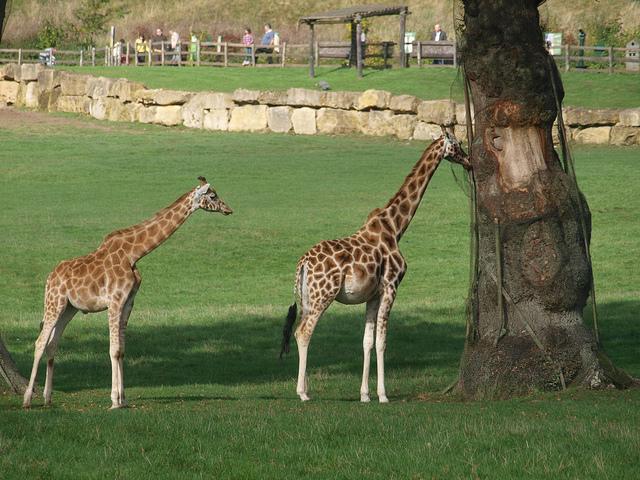How many giraffes are gathered around the tree with some mild damage?
From the following set of four choices, select the accurate answer to respond to the question.
Options: Five, two, four, three. Two. What is there a giant hole taken out of the tree for?
From the following four choices, select the correct answer to address the question.
Options: Giraffes, moose, lumberjacks, skunks. Giraffes. 